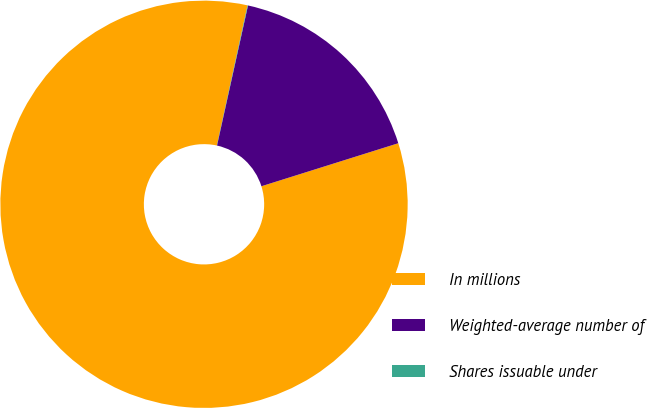<chart> <loc_0><loc_0><loc_500><loc_500><pie_chart><fcel>In millions<fcel>Weighted-average number of<fcel>Shares issuable under<nl><fcel>83.28%<fcel>16.69%<fcel>0.04%<nl></chart> 